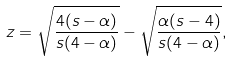<formula> <loc_0><loc_0><loc_500><loc_500>z = \sqrt { \frac { 4 ( s - \alpha ) } { s ( 4 - \alpha ) } } - \sqrt { \frac { \alpha ( s - 4 ) } { s ( 4 - \alpha ) } } ,</formula> 